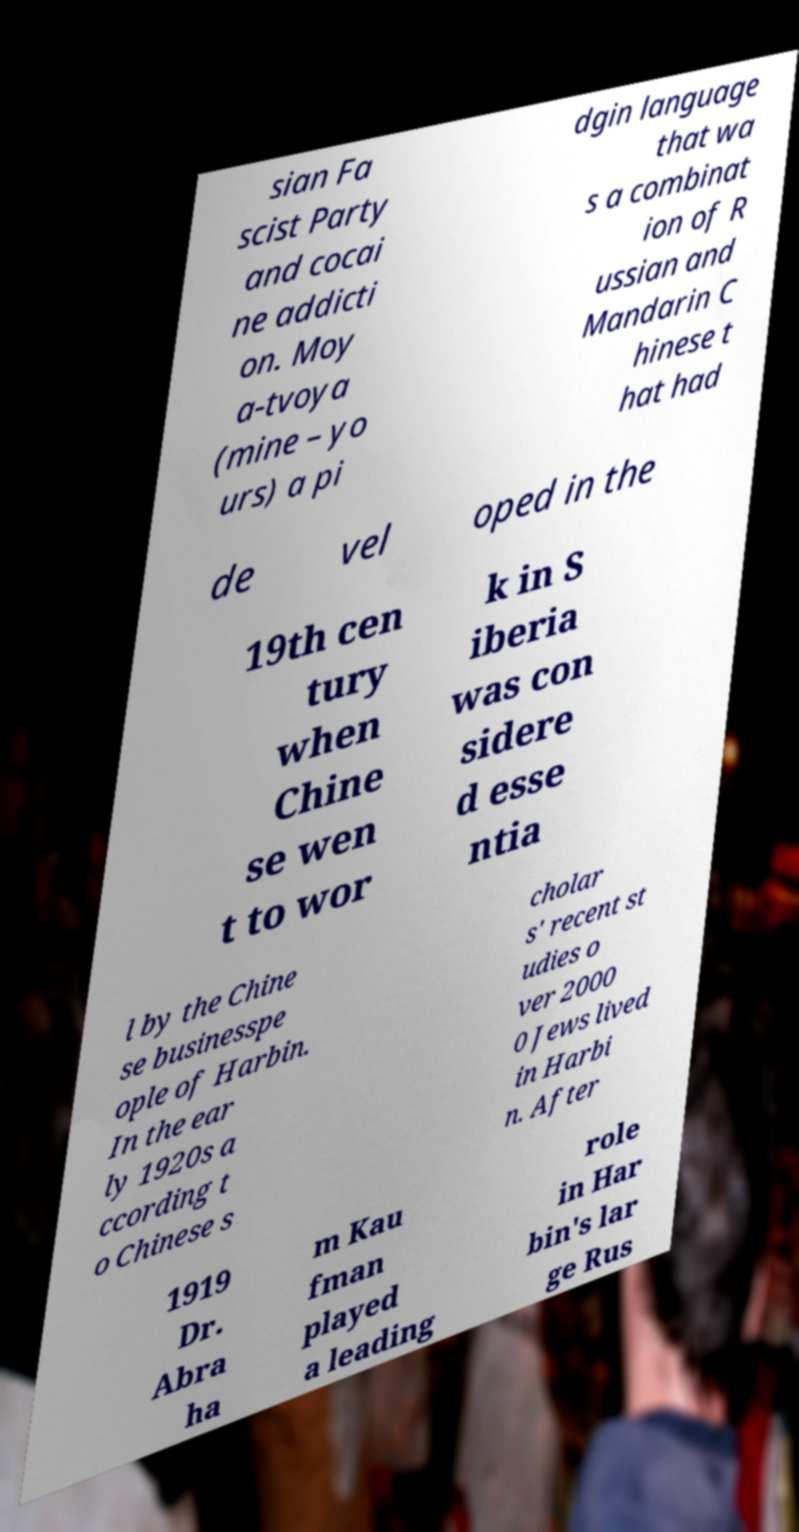Could you assist in decoding the text presented in this image and type it out clearly? sian Fa scist Party and cocai ne addicti on. Moy a-tvoya (mine – yo urs) a pi dgin language that wa s a combinat ion of R ussian and Mandarin C hinese t hat had de vel oped in the 19th cen tury when Chine se wen t to wor k in S iberia was con sidere d esse ntia l by the Chine se businesspe ople of Harbin. In the ear ly 1920s a ccording t o Chinese s cholar s' recent st udies o ver 2000 0 Jews lived in Harbi n. After 1919 Dr. Abra ha m Kau fman played a leading role in Har bin's lar ge Rus 